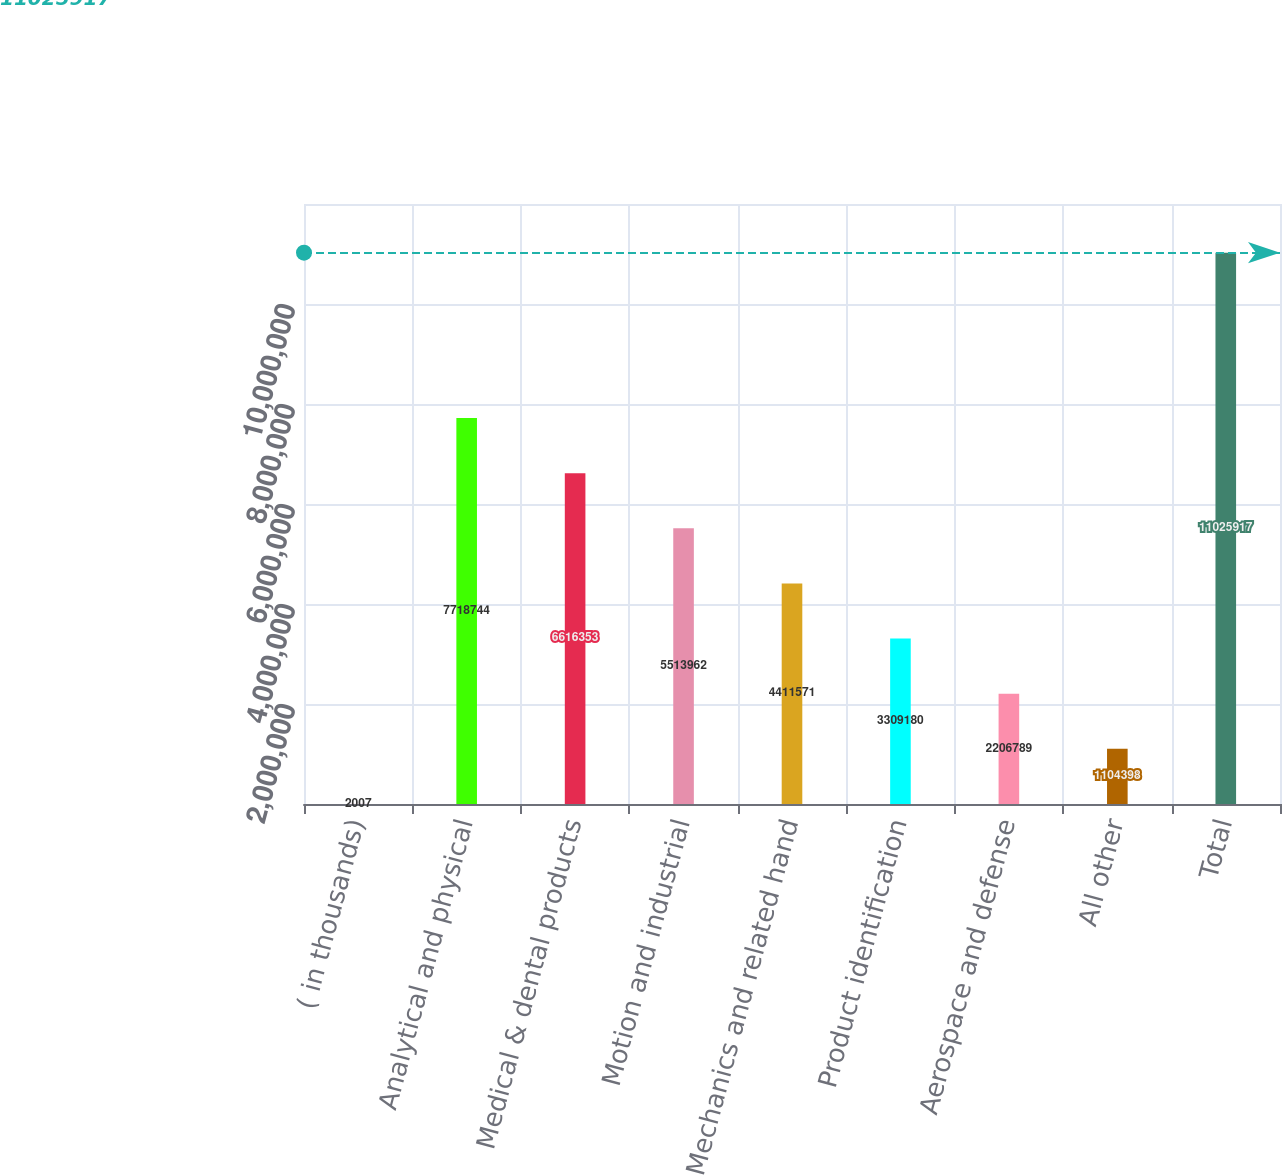Convert chart. <chart><loc_0><loc_0><loc_500><loc_500><bar_chart><fcel>( in thousands)<fcel>Analytical and physical<fcel>Medical & dental products<fcel>Motion and industrial<fcel>Mechanics and related hand<fcel>Product identification<fcel>Aerospace and defense<fcel>All other<fcel>Total<nl><fcel>2007<fcel>7.71874e+06<fcel>6.61635e+06<fcel>5.51396e+06<fcel>4.41157e+06<fcel>3.30918e+06<fcel>2.20679e+06<fcel>1.1044e+06<fcel>1.10259e+07<nl></chart> 